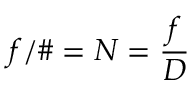<formula> <loc_0><loc_0><loc_500><loc_500>f / \# = N = { \frac { f } { D } }</formula> 